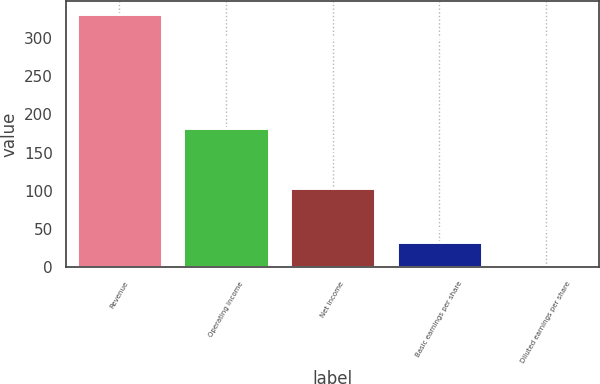<chart> <loc_0><loc_0><loc_500><loc_500><bar_chart><fcel>Revenue<fcel>Operating income<fcel>Net income<fcel>Basic earnings per share<fcel>Diluted earnings per share<nl><fcel>331.2<fcel>182.9<fcel>103.5<fcel>33.73<fcel>0.68<nl></chart> 